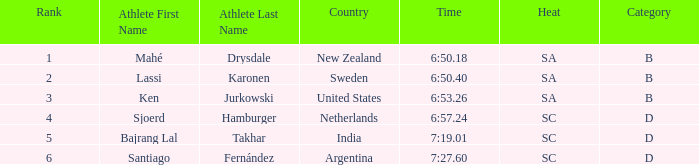What is listed in notes for the athlete, lassi karonen? SA/B. 